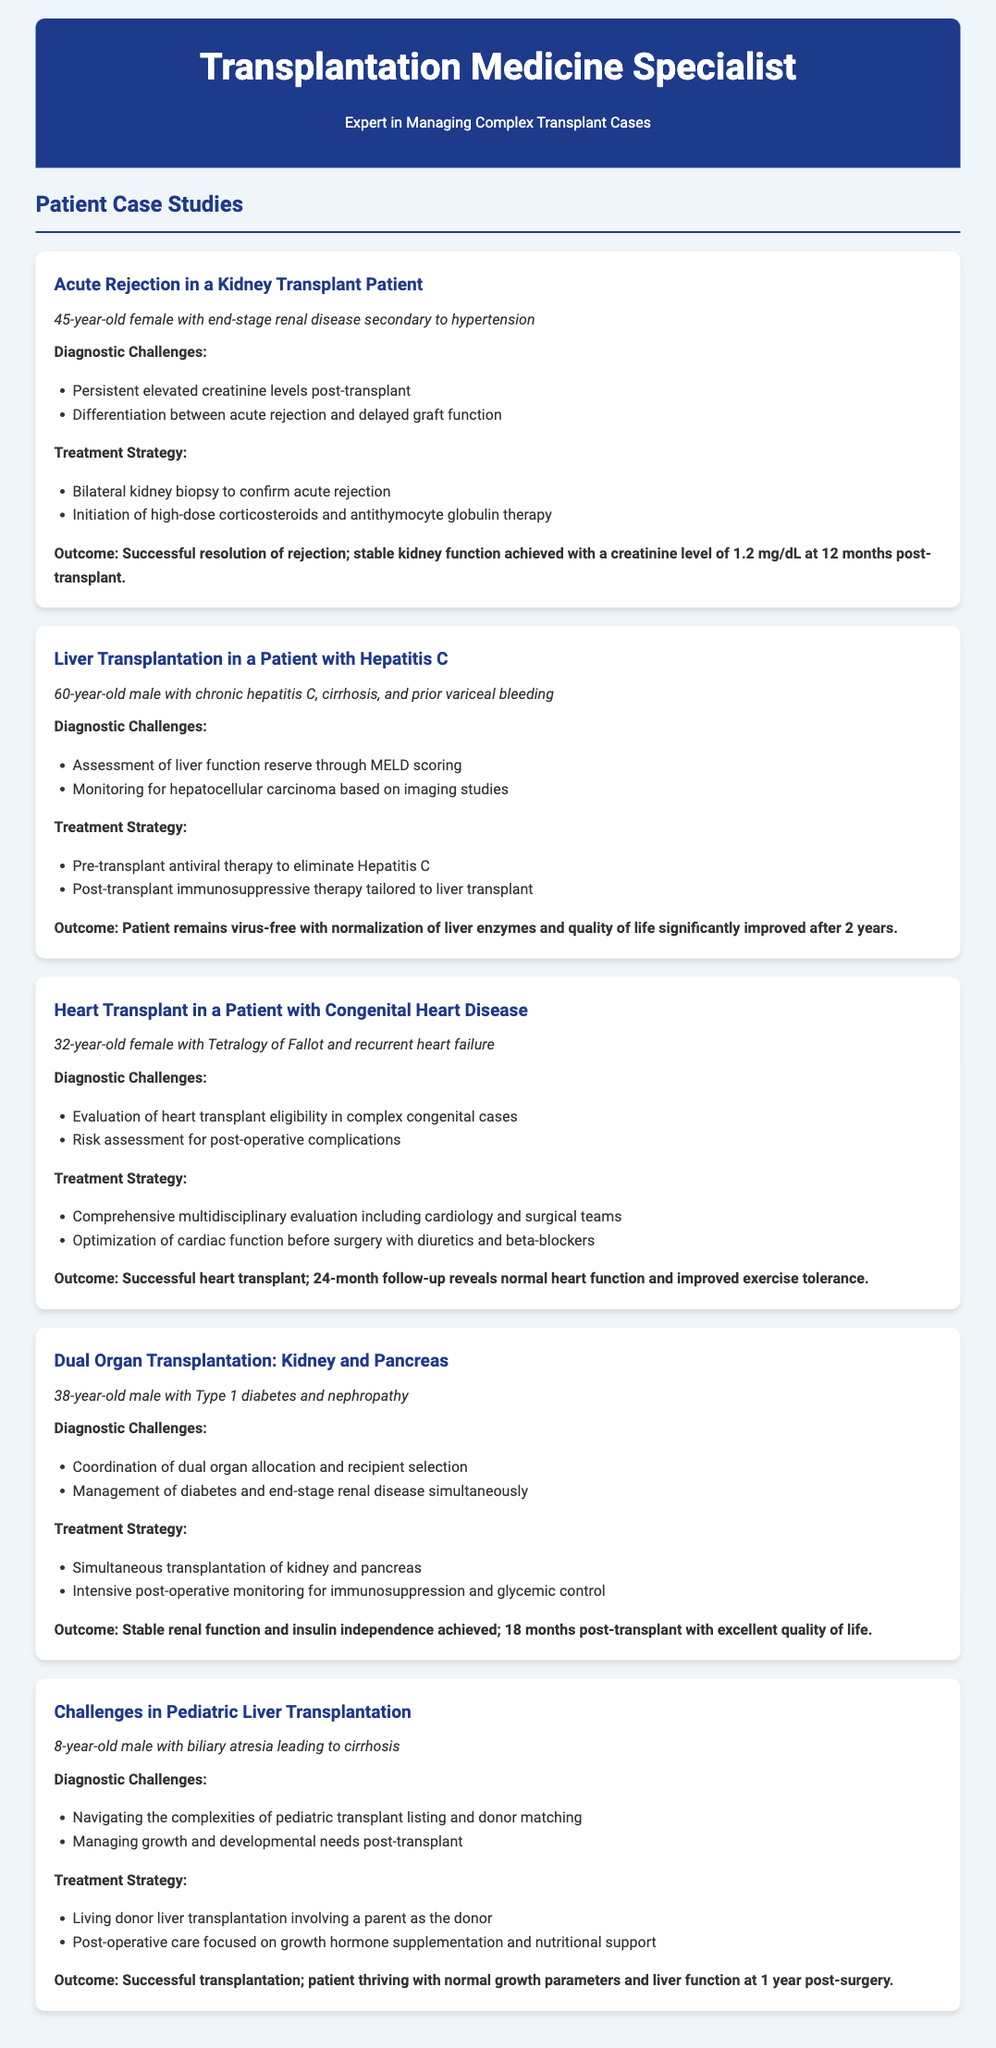What is the age of the female kidney transplant patient? The document states she is a 45-year-old female.
Answer: 45 What was the initial treatment for the male patient with Hepatitis C? The treatment strategy included pre-transplant antiviral therapy to eliminate Hepatitis C.
Answer: Antiviral therapy How many months after the heart transplant was the follow-up conducted? The follow-up for the heart transplant patient was conducted at 24 months post-transplant.
Answer: 24 months What diagnostic challenge was faced in the dual organ transplantation case? The case involved coordinating dual organ allocation and recipient selection.
Answer: Coordination of dual organ allocation What was the outcome for the pediatric liver transplantation patient after one year? The patient is thriving with normal growth parameters and liver function at 1 year post-surgery.
Answer: Thriving with normal growth parameters 